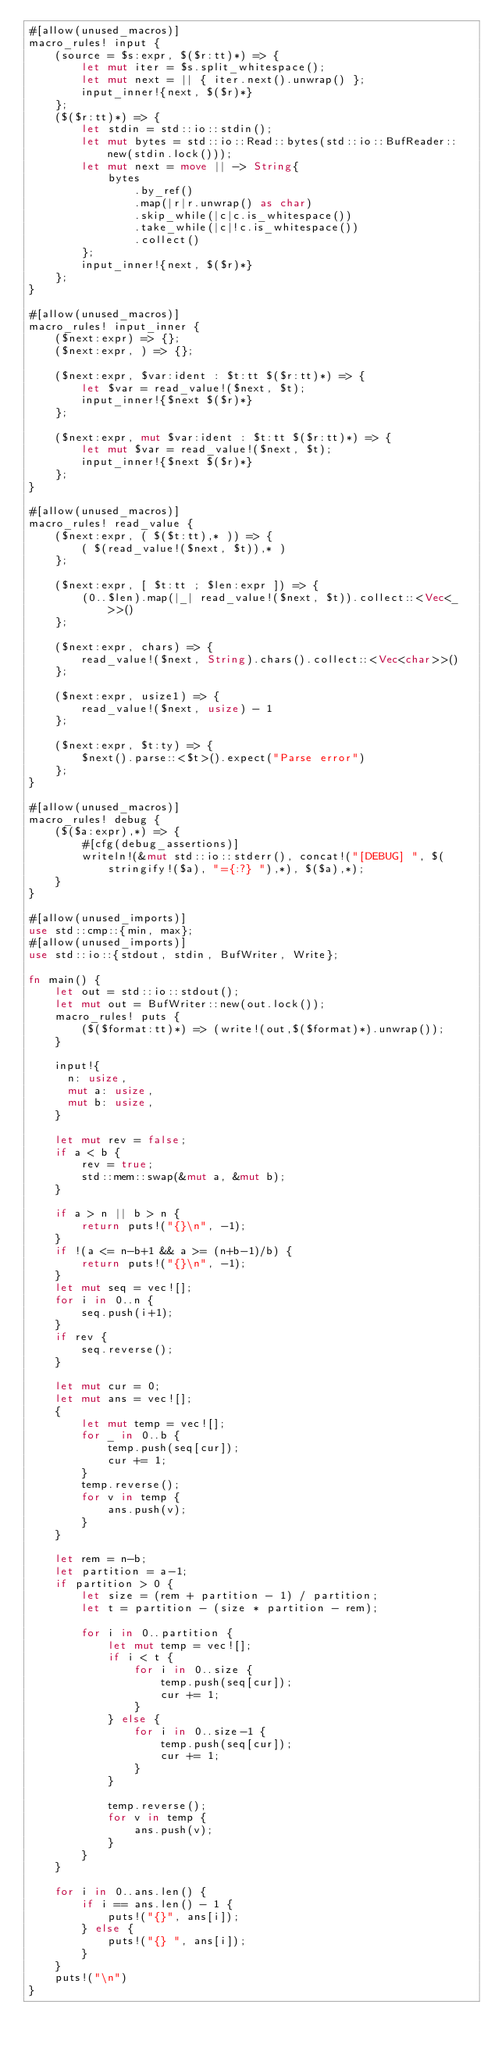Convert code to text. <code><loc_0><loc_0><loc_500><loc_500><_Rust_>#[allow(unused_macros)]
macro_rules! input {
    (source = $s:expr, $($r:tt)*) => {
        let mut iter = $s.split_whitespace();
        let mut next = || { iter.next().unwrap() };
        input_inner!{next, $($r)*}
    };
    ($($r:tt)*) => {
        let stdin = std::io::stdin();
        let mut bytes = std::io::Read::bytes(std::io::BufReader::new(stdin.lock()));
        let mut next = move || -> String{
            bytes
                .by_ref()
                .map(|r|r.unwrap() as char)
                .skip_while(|c|c.is_whitespace())
                .take_while(|c|!c.is_whitespace())
                .collect()
        };
        input_inner!{next, $($r)*}
    };
}

#[allow(unused_macros)]
macro_rules! input_inner {
    ($next:expr) => {};
    ($next:expr, ) => {};

    ($next:expr, $var:ident : $t:tt $($r:tt)*) => {
        let $var = read_value!($next, $t);
        input_inner!{$next $($r)*}
    };

    ($next:expr, mut $var:ident : $t:tt $($r:tt)*) => {
        let mut $var = read_value!($next, $t);
        input_inner!{$next $($r)*}
    };
}

#[allow(unused_macros)]
macro_rules! read_value {
    ($next:expr, ( $($t:tt),* )) => {
        ( $(read_value!($next, $t)),* )
    };

    ($next:expr, [ $t:tt ; $len:expr ]) => {
        (0..$len).map(|_| read_value!($next, $t)).collect::<Vec<_>>()
    };

    ($next:expr, chars) => {
        read_value!($next, String).chars().collect::<Vec<char>>()
    };

    ($next:expr, usize1) => {
        read_value!($next, usize) - 1
    };

    ($next:expr, $t:ty) => {
        $next().parse::<$t>().expect("Parse error")
    };
}

#[allow(unused_macros)]
macro_rules! debug {
    ($($a:expr),*) => {
        #[cfg(debug_assertions)]
        writeln!(&mut std::io::stderr(), concat!("[DEBUG] ", $(stringify!($a), "={:?} "),*), $($a),*);
    }
}

#[allow(unused_imports)]
use std::cmp::{min, max};
#[allow(unused_imports)]
use std::io::{stdout, stdin, BufWriter, Write};

fn main() {
    let out = std::io::stdout();
    let mut out = BufWriter::new(out.lock());
    macro_rules! puts {
        ($($format:tt)*) => (write!(out,$($format)*).unwrap());
    }

    input!{
      n: usize,
      mut a: usize,
      mut b: usize,
    }

    let mut rev = false;
    if a < b {
        rev = true;
        std::mem::swap(&mut a, &mut b);
    }

    if a > n || b > n {
        return puts!("{}\n", -1);
    }
    if !(a <= n-b+1 && a >= (n+b-1)/b) {
        return puts!("{}\n", -1);
    }
    let mut seq = vec![];
    for i in 0..n {
        seq.push(i+1);
    }
    if rev {
        seq.reverse();
    }

    let mut cur = 0;
    let mut ans = vec![];
    {
        let mut temp = vec![];
        for _ in 0..b {
            temp.push(seq[cur]);
            cur += 1;
        }
        temp.reverse();
        for v in temp {
            ans.push(v);
        }
    }

    let rem = n-b;
    let partition = a-1;
    if partition > 0 {
        let size = (rem + partition - 1) / partition;
        let t = partition - (size * partition - rem);

        for i in 0..partition {
            let mut temp = vec![];
            if i < t {
                for i in 0..size {
                    temp.push(seq[cur]);
                    cur += 1;
                }
            } else {
                for i in 0..size-1 {
                    temp.push(seq[cur]);
                    cur += 1;
                }
            }

            temp.reverse();
            for v in temp {
                ans.push(v);
            }
        }
    }

    for i in 0..ans.len() {
        if i == ans.len() - 1 {
            puts!("{}", ans[i]);
        } else {
            puts!("{} ", ans[i]);
        }
    }
    puts!("\n")
}
</code> 